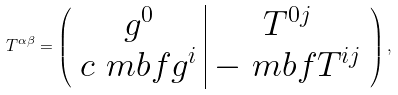<formula> <loc_0><loc_0><loc_500><loc_500>T ^ { \alpha \beta } = \left ( \begin{array} { c | c } g ^ { 0 } & T ^ { 0 j } \\ c \ m b f { g } ^ { i } & - \ m b f { T } ^ { i j } \end{array} \right ) ,</formula> 